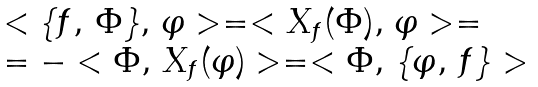Convert formula to latex. <formula><loc_0><loc_0><loc_500><loc_500>\begin{array} { l } < \{ f , \, \Phi \} , \, \varphi > = < X _ { f } ( \Phi ) , \, \varphi > = \\ = - < \Phi , \, X _ { f } ( \varphi ) > = < \Phi , \, \{ \varphi , \, f \} > \end{array}</formula> 